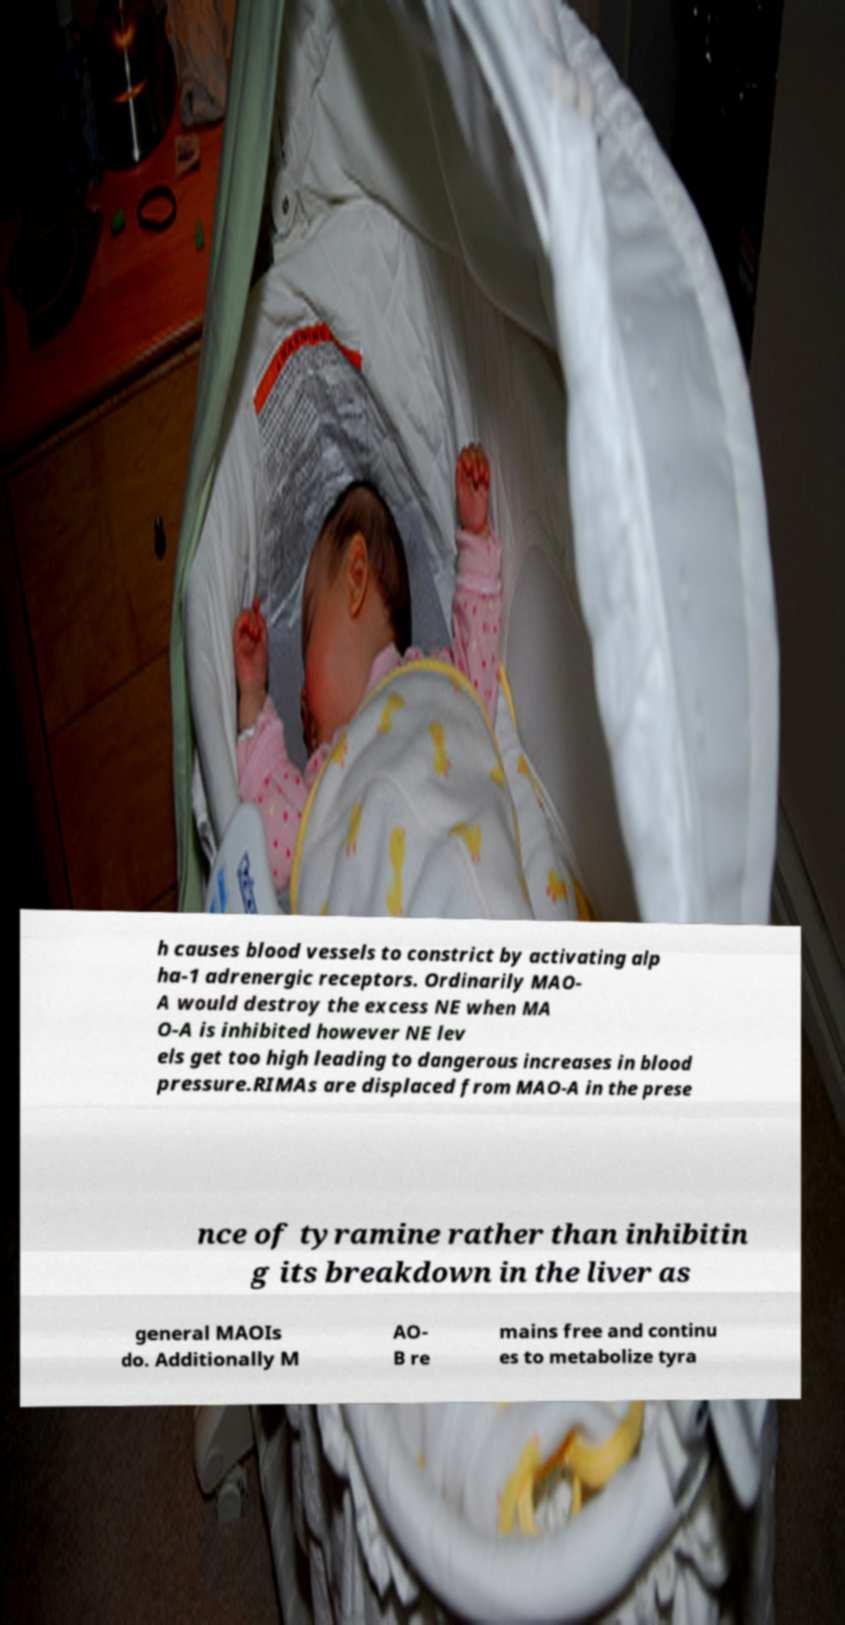Can you accurately transcribe the text from the provided image for me? h causes blood vessels to constrict by activating alp ha-1 adrenergic receptors. Ordinarily MAO- A would destroy the excess NE when MA O-A is inhibited however NE lev els get too high leading to dangerous increases in blood pressure.RIMAs are displaced from MAO-A in the prese nce of tyramine rather than inhibitin g its breakdown in the liver as general MAOIs do. Additionally M AO- B re mains free and continu es to metabolize tyra 